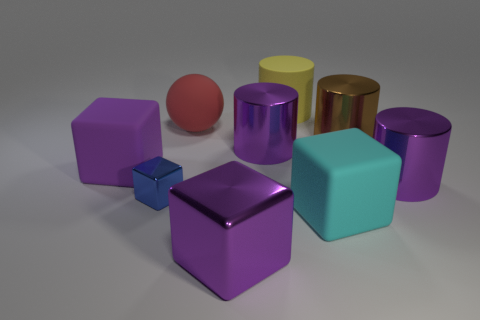Subtract all metallic cylinders. How many cylinders are left? 1 Subtract all purple cubes. How many cubes are left? 2 Subtract 4 cylinders. How many cylinders are left? 0 Subtract all purple spheres. How many blue cylinders are left? 0 Add 1 big rubber cubes. How many objects exist? 10 Subtract all cubes. How many objects are left? 5 Subtract all blue cylinders. Subtract all purple balls. How many cylinders are left? 4 Subtract all red metallic spheres. Subtract all yellow rubber cylinders. How many objects are left? 8 Add 5 large yellow rubber objects. How many large yellow rubber objects are left? 6 Add 5 small blue metallic cylinders. How many small blue metallic cylinders exist? 5 